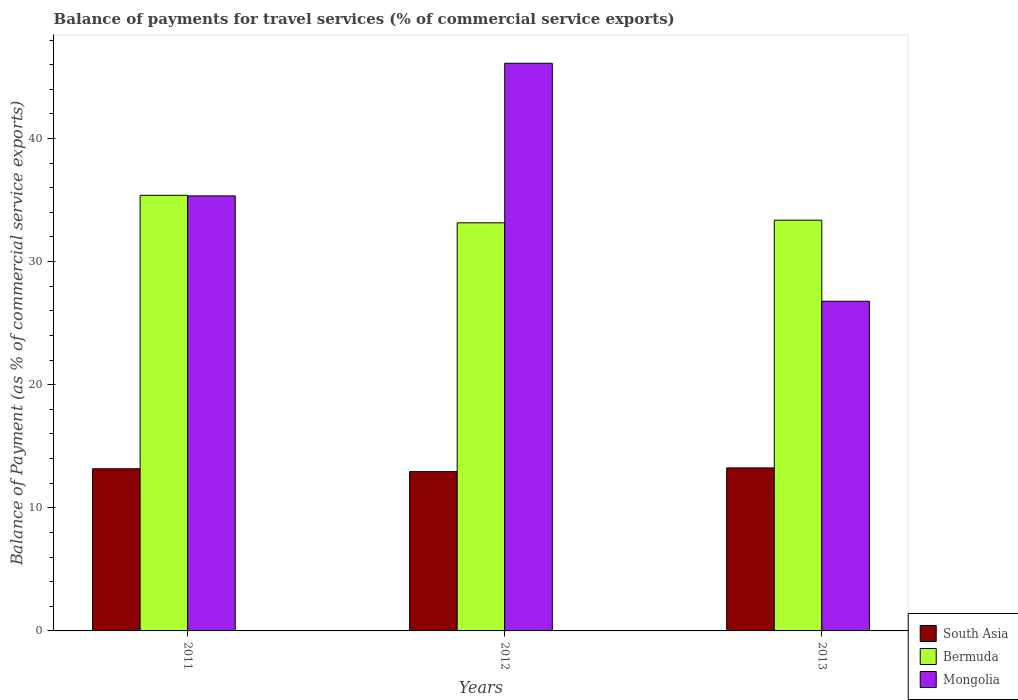How many different coloured bars are there?
Keep it short and to the point. 3. How many bars are there on the 2nd tick from the left?
Provide a succinct answer. 3. How many bars are there on the 2nd tick from the right?
Make the answer very short. 3. What is the label of the 2nd group of bars from the left?
Your answer should be very brief. 2012. In how many cases, is the number of bars for a given year not equal to the number of legend labels?
Keep it short and to the point. 0. What is the balance of payments for travel services in Bermuda in 2011?
Your answer should be compact. 35.39. Across all years, what is the maximum balance of payments for travel services in Mongolia?
Your answer should be very brief. 46.11. Across all years, what is the minimum balance of payments for travel services in Mongolia?
Provide a succinct answer. 26.78. In which year was the balance of payments for travel services in Mongolia minimum?
Provide a succinct answer. 2013. What is the total balance of payments for travel services in Bermuda in the graph?
Ensure brevity in your answer.  101.91. What is the difference between the balance of payments for travel services in South Asia in 2011 and that in 2013?
Make the answer very short. -0.07. What is the difference between the balance of payments for travel services in Mongolia in 2011 and the balance of payments for travel services in Bermuda in 2012?
Offer a very short reply. 2.19. What is the average balance of payments for travel services in South Asia per year?
Offer a very short reply. 13.12. In the year 2012, what is the difference between the balance of payments for travel services in South Asia and balance of payments for travel services in Bermuda?
Provide a short and direct response. -20.21. What is the ratio of the balance of payments for travel services in Bermuda in 2011 to that in 2012?
Your answer should be very brief. 1.07. Is the balance of payments for travel services in South Asia in 2011 less than that in 2013?
Provide a succinct answer. Yes. What is the difference between the highest and the second highest balance of payments for travel services in Mongolia?
Make the answer very short. 10.78. What is the difference between the highest and the lowest balance of payments for travel services in South Asia?
Make the answer very short. 0.3. Is the sum of the balance of payments for travel services in South Asia in 2011 and 2012 greater than the maximum balance of payments for travel services in Mongolia across all years?
Offer a terse response. No. What does the 1st bar from the left in 2012 represents?
Give a very brief answer. South Asia. What does the 1st bar from the right in 2012 represents?
Keep it short and to the point. Mongolia. Are all the bars in the graph horizontal?
Ensure brevity in your answer.  No. How many years are there in the graph?
Offer a very short reply. 3. Are the values on the major ticks of Y-axis written in scientific E-notation?
Provide a short and direct response. No. Does the graph contain grids?
Offer a terse response. No. How are the legend labels stacked?
Provide a succinct answer. Vertical. What is the title of the graph?
Keep it short and to the point. Balance of payments for travel services (% of commercial service exports). Does "Georgia" appear as one of the legend labels in the graph?
Provide a succinct answer. No. What is the label or title of the Y-axis?
Keep it short and to the point. Balance of Payment (as % of commercial service exports). What is the Balance of Payment (as % of commercial service exports) in South Asia in 2011?
Your answer should be compact. 13.17. What is the Balance of Payment (as % of commercial service exports) in Bermuda in 2011?
Provide a succinct answer. 35.39. What is the Balance of Payment (as % of commercial service exports) in Mongolia in 2011?
Provide a succinct answer. 35.34. What is the Balance of Payment (as % of commercial service exports) of South Asia in 2012?
Make the answer very short. 12.94. What is the Balance of Payment (as % of commercial service exports) of Bermuda in 2012?
Provide a succinct answer. 33.15. What is the Balance of Payment (as % of commercial service exports) in Mongolia in 2012?
Offer a very short reply. 46.11. What is the Balance of Payment (as % of commercial service exports) of South Asia in 2013?
Your response must be concise. 13.24. What is the Balance of Payment (as % of commercial service exports) in Bermuda in 2013?
Give a very brief answer. 33.37. What is the Balance of Payment (as % of commercial service exports) of Mongolia in 2013?
Your response must be concise. 26.78. Across all years, what is the maximum Balance of Payment (as % of commercial service exports) of South Asia?
Provide a short and direct response. 13.24. Across all years, what is the maximum Balance of Payment (as % of commercial service exports) in Bermuda?
Your response must be concise. 35.39. Across all years, what is the maximum Balance of Payment (as % of commercial service exports) in Mongolia?
Make the answer very short. 46.11. Across all years, what is the minimum Balance of Payment (as % of commercial service exports) in South Asia?
Provide a succinct answer. 12.94. Across all years, what is the minimum Balance of Payment (as % of commercial service exports) of Bermuda?
Your answer should be very brief. 33.15. Across all years, what is the minimum Balance of Payment (as % of commercial service exports) of Mongolia?
Make the answer very short. 26.78. What is the total Balance of Payment (as % of commercial service exports) in South Asia in the graph?
Make the answer very short. 39.35. What is the total Balance of Payment (as % of commercial service exports) in Bermuda in the graph?
Offer a terse response. 101.91. What is the total Balance of Payment (as % of commercial service exports) in Mongolia in the graph?
Ensure brevity in your answer.  108.23. What is the difference between the Balance of Payment (as % of commercial service exports) of South Asia in 2011 and that in 2012?
Offer a very short reply. 0.23. What is the difference between the Balance of Payment (as % of commercial service exports) of Bermuda in 2011 and that in 2012?
Keep it short and to the point. 2.24. What is the difference between the Balance of Payment (as % of commercial service exports) of Mongolia in 2011 and that in 2012?
Make the answer very short. -10.78. What is the difference between the Balance of Payment (as % of commercial service exports) of South Asia in 2011 and that in 2013?
Your response must be concise. -0.07. What is the difference between the Balance of Payment (as % of commercial service exports) of Bermuda in 2011 and that in 2013?
Your answer should be very brief. 2.02. What is the difference between the Balance of Payment (as % of commercial service exports) in Mongolia in 2011 and that in 2013?
Offer a terse response. 8.56. What is the difference between the Balance of Payment (as % of commercial service exports) of South Asia in 2012 and that in 2013?
Make the answer very short. -0.3. What is the difference between the Balance of Payment (as % of commercial service exports) in Bermuda in 2012 and that in 2013?
Give a very brief answer. -0.21. What is the difference between the Balance of Payment (as % of commercial service exports) in Mongolia in 2012 and that in 2013?
Your answer should be very brief. 19.33. What is the difference between the Balance of Payment (as % of commercial service exports) of South Asia in 2011 and the Balance of Payment (as % of commercial service exports) of Bermuda in 2012?
Provide a succinct answer. -19.98. What is the difference between the Balance of Payment (as % of commercial service exports) of South Asia in 2011 and the Balance of Payment (as % of commercial service exports) of Mongolia in 2012?
Give a very brief answer. -32.94. What is the difference between the Balance of Payment (as % of commercial service exports) of Bermuda in 2011 and the Balance of Payment (as % of commercial service exports) of Mongolia in 2012?
Provide a succinct answer. -10.73. What is the difference between the Balance of Payment (as % of commercial service exports) in South Asia in 2011 and the Balance of Payment (as % of commercial service exports) in Bermuda in 2013?
Offer a terse response. -20.2. What is the difference between the Balance of Payment (as % of commercial service exports) in South Asia in 2011 and the Balance of Payment (as % of commercial service exports) in Mongolia in 2013?
Your response must be concise. -13.61. What is the difference between the Balance of Payment (as % of commercial service exports) in Bermuda in 2011 and the Balance of Payment (as % of commercial service exports) in Mongolia in 2013?
Offer a very short reply. 8.61. What is the difference between the Balance of Payment (as % of commercial service exports) in South Asia in 2012 and the Balance of Payment (as % of commercial service exports) in Bermuda in 2013?
Keep it short and to the point. -20.43. What is the difference between the Balance of Payment (as % of commercial service exports) of South Asia in 2012 and the Balance of Payment (as % of commercial service exports) of Mongolia in 2013?
Provide a succinct answer. -13.84. What is the difference between the Balance of Payment (as % of commercial service exports) in Bermuda in 2012 and the Balance of Payment (as % of commercial service exports) in Mongolia in 2013?
Make the answer very short. 6.37. What is the average Balance of Payment (as % of commercial service exports) of South Asia per year?
Provide a succinct answer. 13.12. What is the average Balance of Payment (as % of commercial service exports) in Bermuda per year?
Make the answer very short. 33.97. What is the average Balance of Payment (as % of commercial service exports) of Mongolia per year?
Your response must be concise. 36.08. In the year 2011, what is the difference between the Balance of Payment (as % of commercial service exports) in South Asia and Balance of Payment (as % of commercial service exports) in Bermuda?
Offer a very short reply. -22.22. In the year 2011, what is the difference between the Balance of Payment (as % of commercial service exports) of South Asia and Balance of Payment (as % of commercial service exports) of Mongolia?
Your answer should be compact. -22.17. In the year 2011, what is the difference between the Balance of Payment (as % of commercial service exports) of Bermuda and Balance of Payment (as % of commercial service exports) of Mongolia?
Your answer should be very brief. 0.05. In the year 2012, what is the difference between the Balance of Payment (as % of commercial service exports) in South Asia and Balance of Payment (as % of commercial service exports) in Bermuda?
Your answer should be compact. -20.21. In the year 2012, what is the difference between the Balance of Payment (as % of commercial service exports) in South Asia and Balance of Payment (as % of commercial service exports) in Mongolia?
Offer a very short reply. -33.17. In the year 2012, what is the difference between the Balance of Payment (as % of commercial service exports) of Bermuda and Balance of Payment (as % of commercial service exports) of Mongolia?
Give a very brief answer. -12.96. In the year 2013, what is the difference between the Balance of Payment (as % of commercial service exports) of South Asia and Balance of Payment (as % of commercial service exports) of Bermuda?
Your response must be concise. -20.13. In the year 2013, what is the difference between the Balance of Payment (as % of commercial service exports) of South Asia and Balance of Payment (as % of commercial service exports) of Mongolia?
Provide a succinct answer. -13.54. In the year 2013, what is the difference between the Balance of Payment (as % of commercial service exports) in Bermuda and Balance of Payment (as % of commercial service exports) in Mongolia?
Offer a terse response. 6.59. What is the ratio of the Balance of Payment (as % of commercial service exports) of South Asia in 2011 to that in 2012?
Your response must be concise. 1.02. What is the ratio of the Balance of Payment (as % of commercial service exports) of Bermuda in 2011 to that in 2012?
Give a very brief answer. 1.07. What is the ratio of the Balance of Payment (as % of commercial service exports) of Mongolia in 2011 to that in 2012?
Keep it short and to the point. 0.77. What is the ratio of the Balance of Payment (as % of commercial service exports) of South Asia in 2011 to that in 2013?
Your answer should be compact. 0.99. What is the ratio of the Balance of Payment (as % of commercial service exports) in Bermuda in 2011 to that in 2013?
Ensure brevity in your answer.  1.06. What is the ratio of the Balance of Payment (as % of commercial service exports) of Mongolia in 2011 to that in 2013?
Give a very brief answer. 1.32. What is the ratio of the Balance of Payment (as % of commercial service exports) of South Asia in 2012 to that in 2013?
Offer a terse response. 0.98. What is the ratio of the Balance of Payment (as % of commercial service exports) in Bermuda in 2012 to that in 2013?
Provide a short and direct response. 0.99. What is the ratio of the Balance of Payment (as % of commercial service exports) in Mongolia in 2012 to that in 2013?
Ensure brevity in your answer.  1.72. What is the difference between the highest and the second highest Balance of Payment (as % of commercial service exports) of South Asia?
Provide a succinct answer. 0.07. What is the difference between the highest and the second highest Balance of Payment (as % of commercial service exports) in Bermuda?
Your answer should be compact. 2.02. What is the difference between the highest and the second highest Balance of Payment (as % of commercial service exports) of Mongolia?
Make the answer very short. 10.78. What is the difference between the highest and the lowest Balance of Payment (as % of commercial service exports) of South Asia?
Make the answer very short. 0.3. What is the difference between the highest and the lowest Balance of Payment (as % of commercial service exports) of Bermuda?
Provide a short and direct response. 2.24. What is the difference between the highest and the lowest Balance of Payment (as % of commercial service exports) of Mongolia?
Provide a succinct answer. 19.33. 